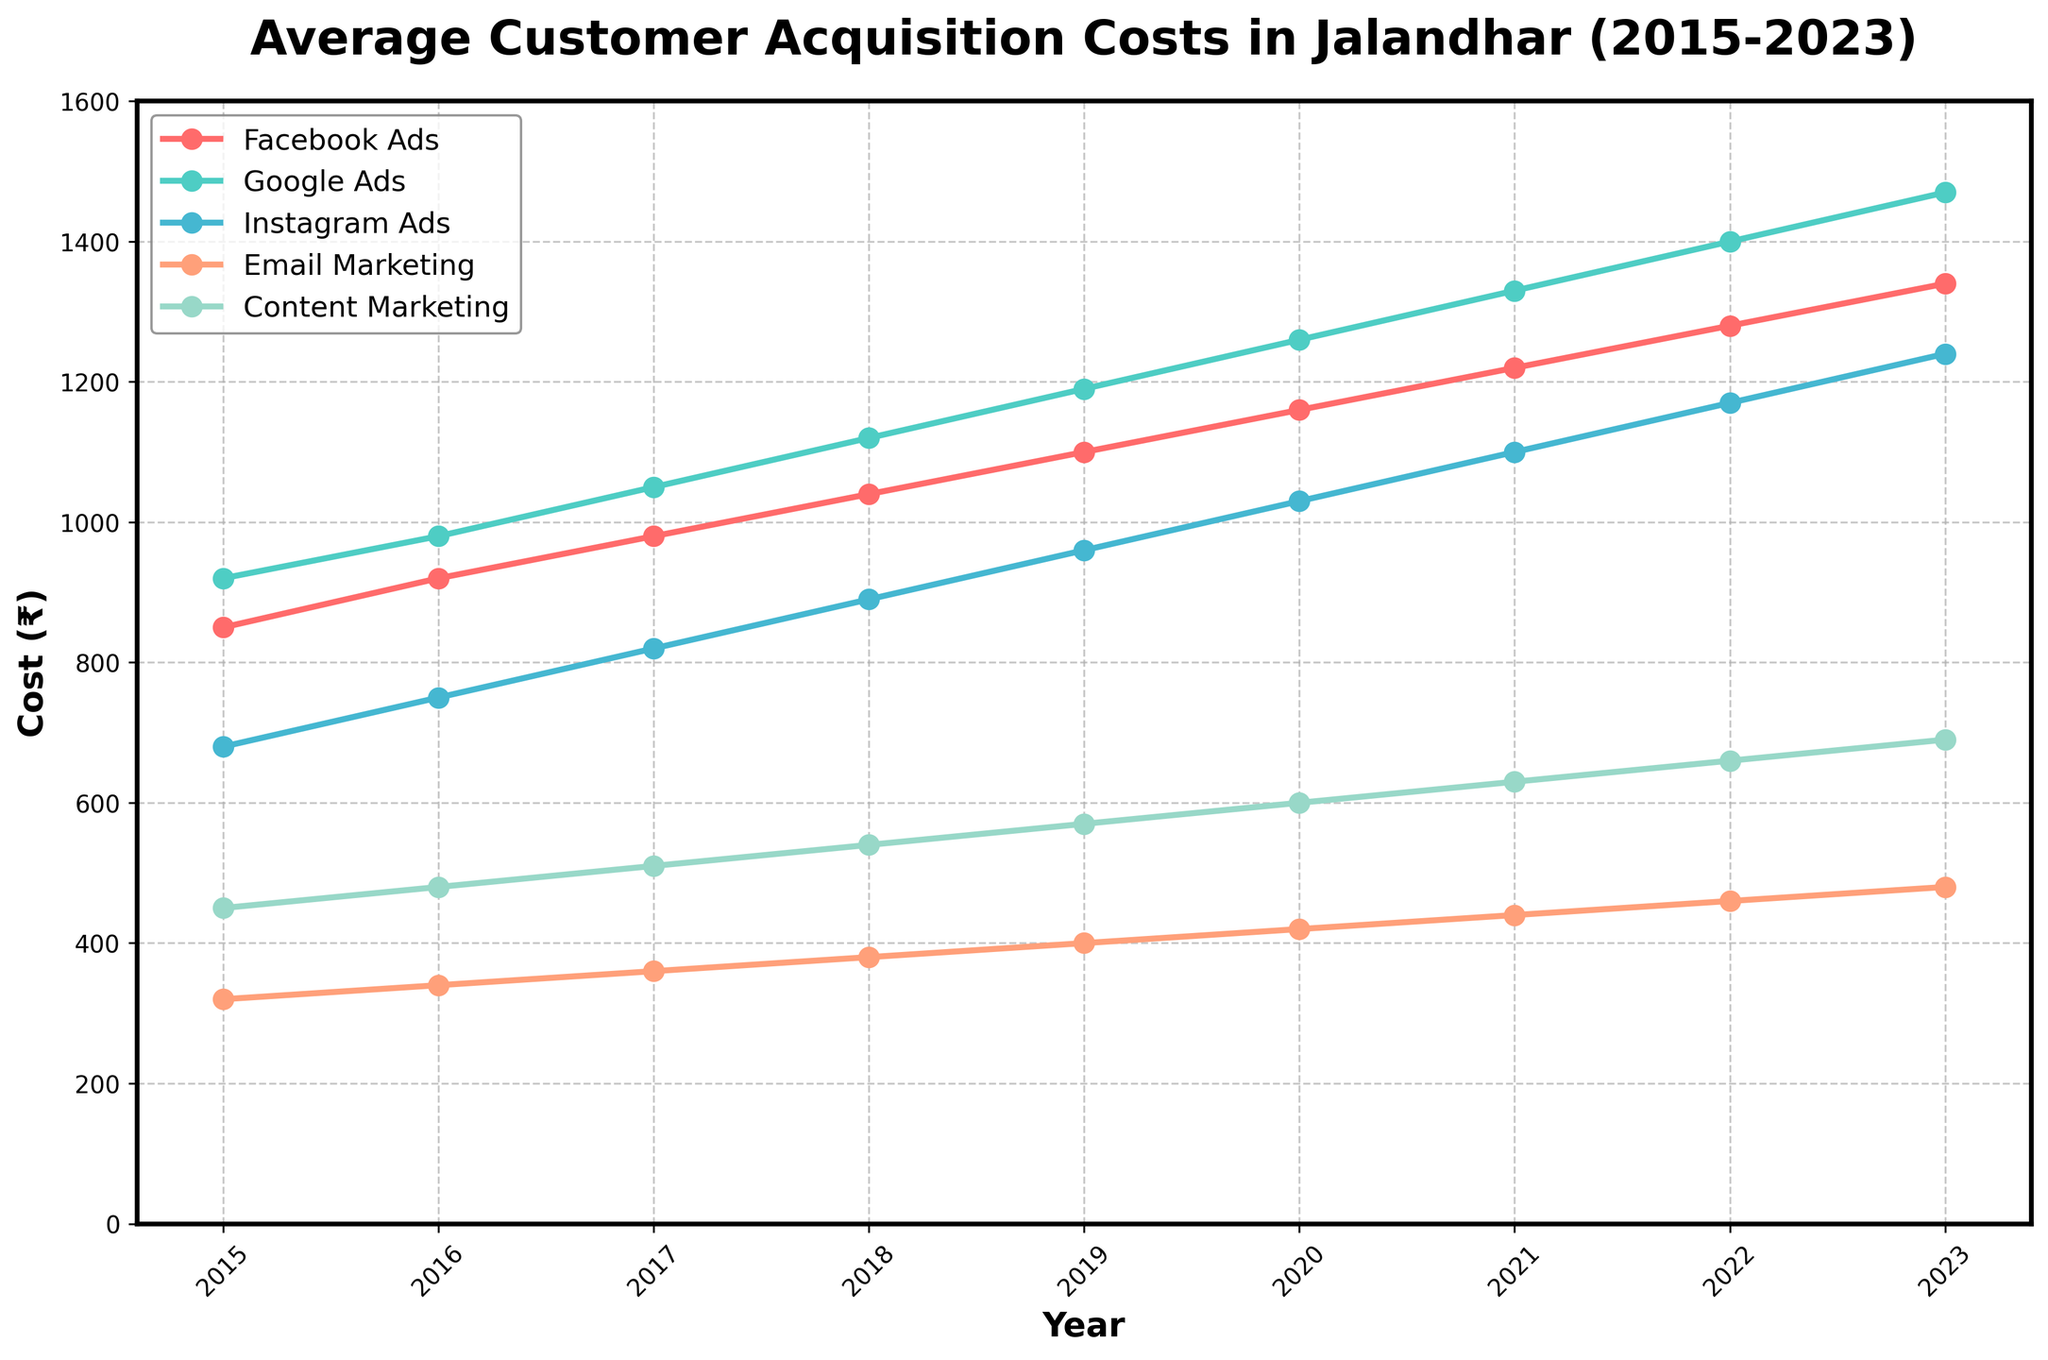What is the trend of Facebook Ads cost from 2015 to 2023? Look at the line representing Facebook Ads. It starts lower in 2015 and steadily increases each year until 2023.
Answer: It increases steadily Which digital marketing strategy had the highest customer acquisition cost in 2023? Identify the highest point on the 2023 axis across all lines. The Google Ads line peaks at the highest point (1470 ₹).
Answer: Google Ads Between 2015 and 2023, which digital marketing strategy has shown the smallest increase in customer acquisition cost? Compare the difference in the cost from 2015 to 2023 for all strategies. Email Marketing increased from 320 ₹ to 480 ₹, which is the smallest increase of 160 ₹.
Answer: Email Marketing How much higher was the Google Ads cost compared to the Facebook Ads cost in 2023? Subtract the Facebook Ads cost from the Google Ads cost for 2023. 1470 ₹ - 1340 ₹ = 130 ₹.
Answer: 130 ₹ What is the average customer acquisition cost for Instagram Ads over the entire period? Sum all the values for Instagram Ads from 2015 to 2023 and divide by the number of years (9). (680+750+820+890+960+1030+1100+1170+1240)/9 = 960.
Answer: 960 Which strategy had the lowest customer acquisition cost in 2016? Compare the points of all strategies for the year 2016. Email Marketing had the lowest cost of 340 ₹.
Answer: Email Marketing In which year did Content Marketing reach a customer acquisition cost of 570 ₹? Look along the Content Marketing line and find the year where it intersects with the 570 ₹ mark. It intersects in 2019.
Answer: 2019 By how much did the cost of Email Marketing increase from 2015 to 2020? Subtract the 2015 cost from the 2020 cost for Email Marketing. 420 ₹ - 320 ₹ = 100 ₹.
Answer: 100 ₹ Which strategy saw the most consistent annual increase in customer acquisition cost from 2015 to 2023? Evaluate the smoothness and consistency of the lines. Facebook Ads show a very consistent annual increase, with no sudden jumps or drops.
Answer: Facebook Ads 